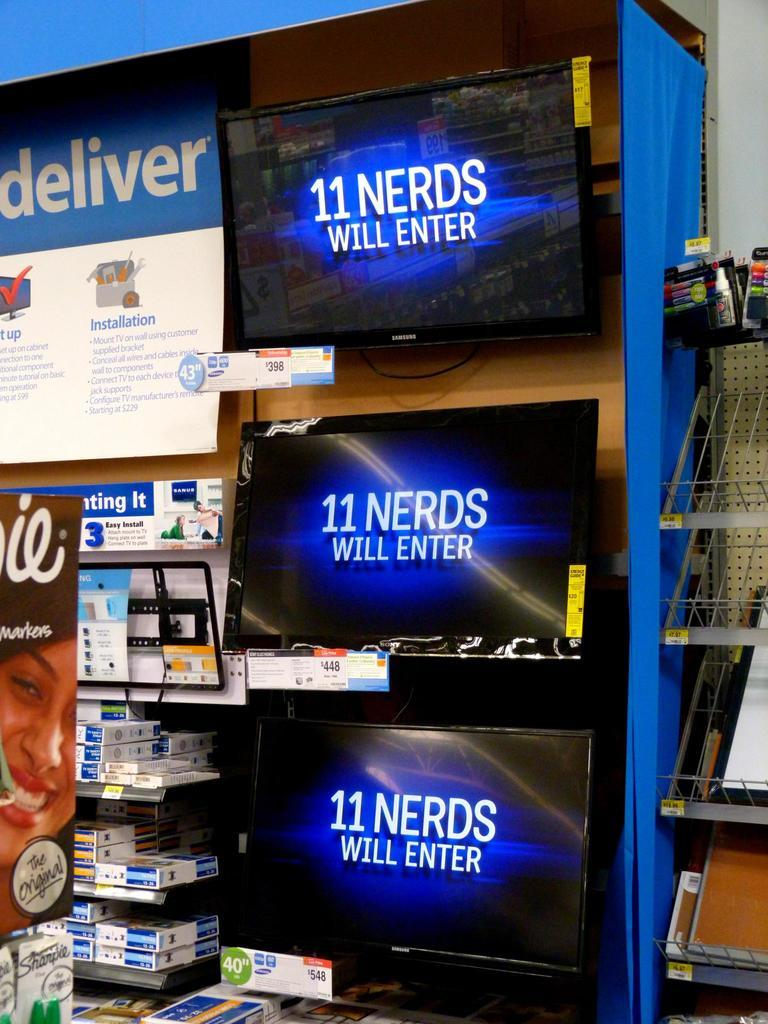<image>
Present a compact description of the photo's key features. Three screens display the message "11 nerds will enter." 